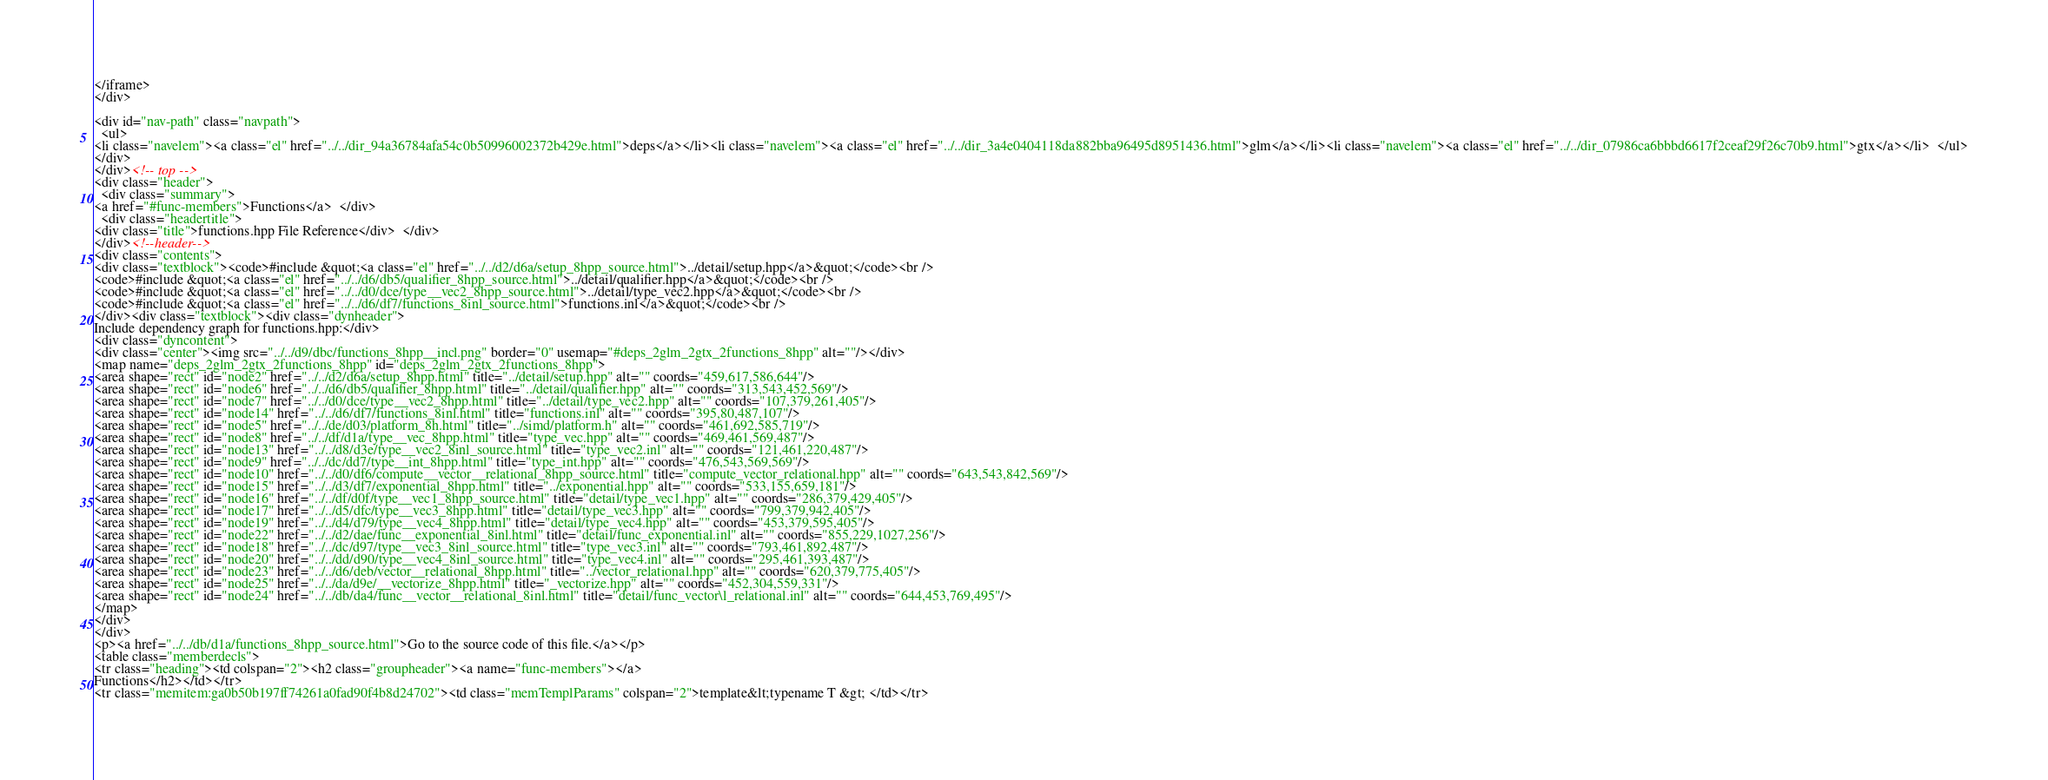Convert code to text. <code><loc_0><loc_0><loc_500><loc_500><_HTML_></iframe>
</div>

<div id="nav-path" class="navpath">
  <ul>
<li class="navelem"><a class="el" href="../../dir_94a36784afa54c0b50996002372b429e.html">deps</a></li><li class="navelem"><a class="el" href="../../dir_3a4e0404118da882bba96495d8951436.html">glm</a></li><li class="navelem"><a class="el" href="../../dir_07986ca6bbbd6617f2ceaf29f26c70b9.html">gtx</a></li>  </ul>
</div>
</div><!-- top -->
<div class="header">
  <div class="summary">
<a href="#func-members">Functions</a>  </div>
  <div class="headertitle">
<div class="title">functions.hpp File Reference</div>  </div>
</div><!--header-->
<div class="contents">
<div class="textblock"><code>#include &quot;<a class="el" href="../../d2/d6a/setup_8hpp_source.html">../detail/setup.hpp</a>&quot;</code><br />
<code>#include &quot;<a class="el" href="../../d6/db5/qualifier_8hpp_source.html">../detail/qualifier.hpp</a>&quot;</code><br />
<code>#include &quot;<a class="el" href="../../d0/dce/type__vec2_8hpp_source.html">../detail/type_vec2.hpp</a>&quot;</code><br />
<code>#include &quot;<a class="el" href="../../d6/df7/functions_8inl_source.html">functions.inl</a>&quot;</code><br />
</div><div class="textblock"><div class="dynheader">
Include dependency graph for functions.hpp:</div>
<div class="dyncontent">
<div class="center"><img src="../../d9/dbc/functions_8hpp__incl.png" border="0" usemap="#deps_2glm_2gtx_2functions_8hpp" alt=""/></div>
<map name="deps_2glm_2gtx_2functions_8hpp" id="deps_2glm_2gtx_2functions_8hpp">
<area shape="rect" id="node2" href="../../d2/d6a/setup_8hpp.html" title="../detail/setup.hpp" alt="" coords="459,617,586,644"/>
<area shape="rect" id="node6" href="../../d6/db5/qualifier_8hpp.html" title="../detail/qualifier.hpp" alt="" coords="313,543,452,569"/>
<area shape="rect" id="node7" href="../../d0/dce/type__vec2_8hpp.html" title="../detail/type_vec2.hpp" alt="" coords="107,379,261,405"/>
<area shape="rect" id="node14" href="../../d6/df7/functions_8inl.html" title="functions.inl" alt="" coords="395,80,487,107"/>
<area shape="rect" id="node5" href="../../de/d03/platform_8h.html" title="../simd/platform.h" alt="" coords="461,692,585,719"/>
<area shape="rect" id="node8" href="../../df/d1a/type__vec_8hpp.html" title="type_vec.hpp" alt="" coords="469,461,569,487"/>
<area shape="rect" id="node13" href="../../d8/d3e/type__vec2_8inl_source.html" title="type_vec2.inl" alt="" coords="121,461,220,487"/>
<area shape="rect" id="node9" href="../../dc/dd7/type__int_8hpp.html" title="type_int.hpp" alt="" coords="476,543,569,569"/>
<area shape="rect" id="node10" href="../../d0/df6/compute__vector__relational_8hpp_source.html" title="compute_vector_relational.hpp" alt="" coords="643,543,842,569"/>
<area shape="rect" id="node15" href="../../d3/df7/exponential_8hpp.html" title="../exponential.hpp" alt="" coords="533,155,659,181"/>
<area shape="rect" id="node16" href="../../df/d0f/type__vec1_8hpp_source.html" title="detail/type_vec1.hpp" alt="" coords="286,379,429,405"/>
<area shape="rect" id="node17" href="../../d5/dfc/type__vec3_8hpp.html" title="detail/type_vec3.hpp" alt="" coords="799,379,942,405"/>
<area shape="rect" id="node19" href="../../d4/d79/type__vec4_8hpp.html" title="detail/type_vec4.hpp" alt="" coords="453,379,595,405"/>
<area shape="rect" id="node22" href="../../d2/dae/func__exponential_8inl.html" title="detail/func_exponential.inl" alt="" coords="855,229,1027,256"/>
<area shape="rect" id="node18" href="../../dc/d97/type__vec3_8inl_source.html" title="type_vec3.inl" alt="" coords="793,461,892,487"/>
<area shape="rect" id="node20" href="../../dd/d90/type__vec4_8inl_source.html" title="type_vec4.inl" alt="" coords="295,461,393,487"/>
<area shape="rect" id="node23" href="../../d6/deb/vector__relational_8hpp.html" title="../vector_relational.hpp" alt="" coords="620,379,775,405"/>
<area shape="rect" id="node25" href="../../da/d9e/__vectorize_8hpp.html" title="_vectorize.hpp" alt="" coords="452,304,559,331"/>
<area shape="rect" id="node24" href="../../db/da4/func__vector__relational_8inl.html" title="detail/func_vector\l_relational.inl" alt="" coords="644,453,769,495"/>
</map>
</div>
</div>
<p><a href="../../db/d1a/functions_8hpp_source.html">Go to the source code of this file.</a></p>
<table class="memberdecls">
<tr class="heading"><td colspan="2"><h2 class="groupheader"><a name="func-members"></a>
Functions</h2></td></tr>
<tr class="memitem:ga0b50b197ff74261a0fad90f4b8d24702"><td class="memTemplParams" colspan="2">template&lt;typename T &gt; </td></tr></code> 